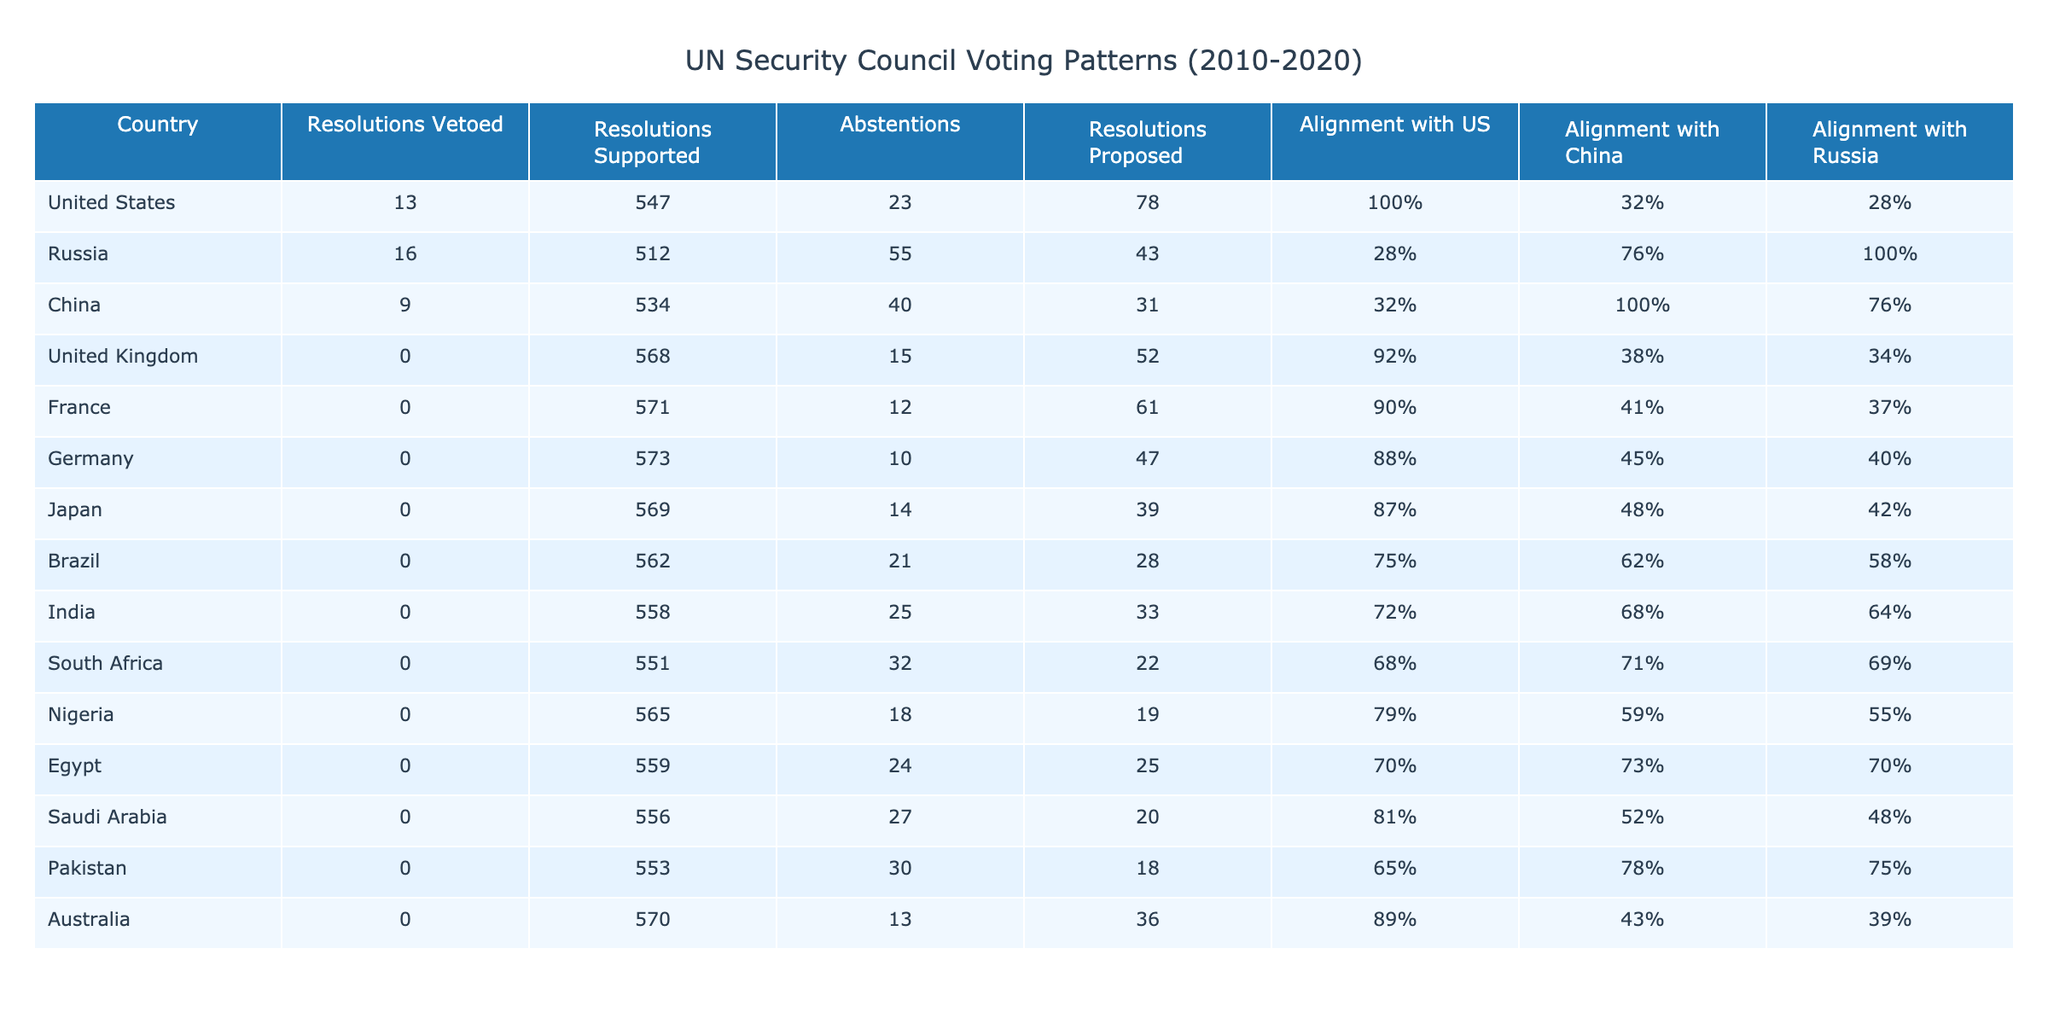What is the country that vetoed the most resolutions? By reviewing the "Resolutions Vetoed" column, we see that Russia vetoed 16 resolutions, which is the highest in the table.
Answer: Russia How many resolutions did the United States support from 2010 to 2020? Referring to the "Resolutions Supported" column for the United States, it shows 547 resolutions supported.
Answer: 547 Which country had the highest alignment with China? Looking at the "Alignment with China" column, China has 100% alignment, which is the highest percentage listed.
Answer: China What are the total resolutions proposed by the countries listed? To find the total resolutions proposed, we add up the values from the "Resolutions Proposed" column: 78 + 43 + 31 + 52 + 61 + 47 + 39 + 28 + 33 + 22 + 19 + 25 + 20 + 18 + 36 = 765.
Answer: 765 Is it true that all countries listed abstained from voting at some point? By reviewing the "Abstentions" column, we see that every country has at least one abstention (numbers greater than zero), confirming the statement is true.
Answer: Yes What is the average number of resolutions vetoed by the countries other than the United States? Excluding the United States, the total vetoes of the other countries are 16 (Russia) + 9 (China) + 0 (UK) + 0 (France) + 0 (Germany) + 0 (Japan) + 0 (Brazil) + 0 (India) + 0 (South Africa) + 0 (Nigeria) + 0 (Egypt) + 0 (Saudi Arabia) + 0 (Pakistan) + 0 (Australia) = 25. There are 14 countries, so the average is 25/14 ≈ 1.79.
Answer: Approximately 1.79 Which country had the highest number of resolutions supported combined with the US's vetoed resolutions? For each country, calculate the sum of "Resolutions Supported" and "Resolutions Vetoed": US (547 + 13 = 560), Russia (512 + 16 = 528), China (534 + 9 = 543), UK (568 + 0 = 568), France (571 + 0 = 571), Germany (573 + 0 = 573), Japan (569 + 0 = 569), Brazil (562 + 0 = 562), India (558 + 0 = 558), South Africa (551 + 0 = 551), Nigeria (565 + 0 = 565), Egypt (559 + 0 = 559), Saudi Arabia (556 + 0 = 556), Pakistan (553 + 0 = 553), Australia (570 + 0 = 570). The highest is France with 571.
Answer: France How do the alignment percentages with the US and China compare for India? By reviewing the "Alignment with US" (72%) and "Alignment with China" (68%) for India, we see that India's alignment with the US is higher than with China.
Answer: US alignment is higher 